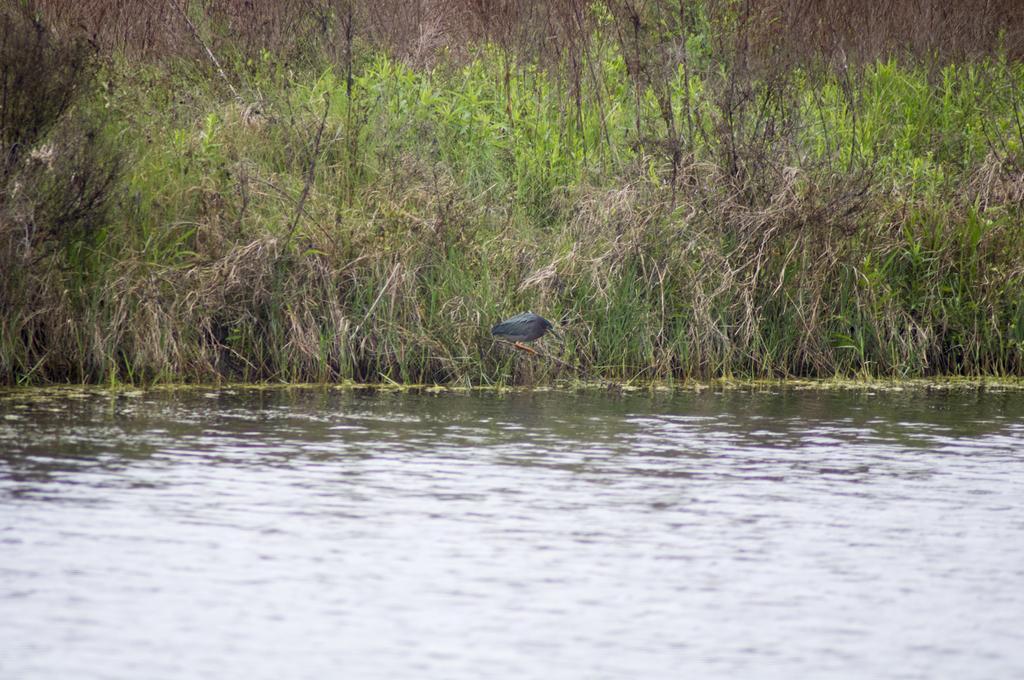Could you give a brief overview of what you see in this image? In the image there is a pond in the front and behind it there is a bird standing on a stick on land covered with plants all over it. 